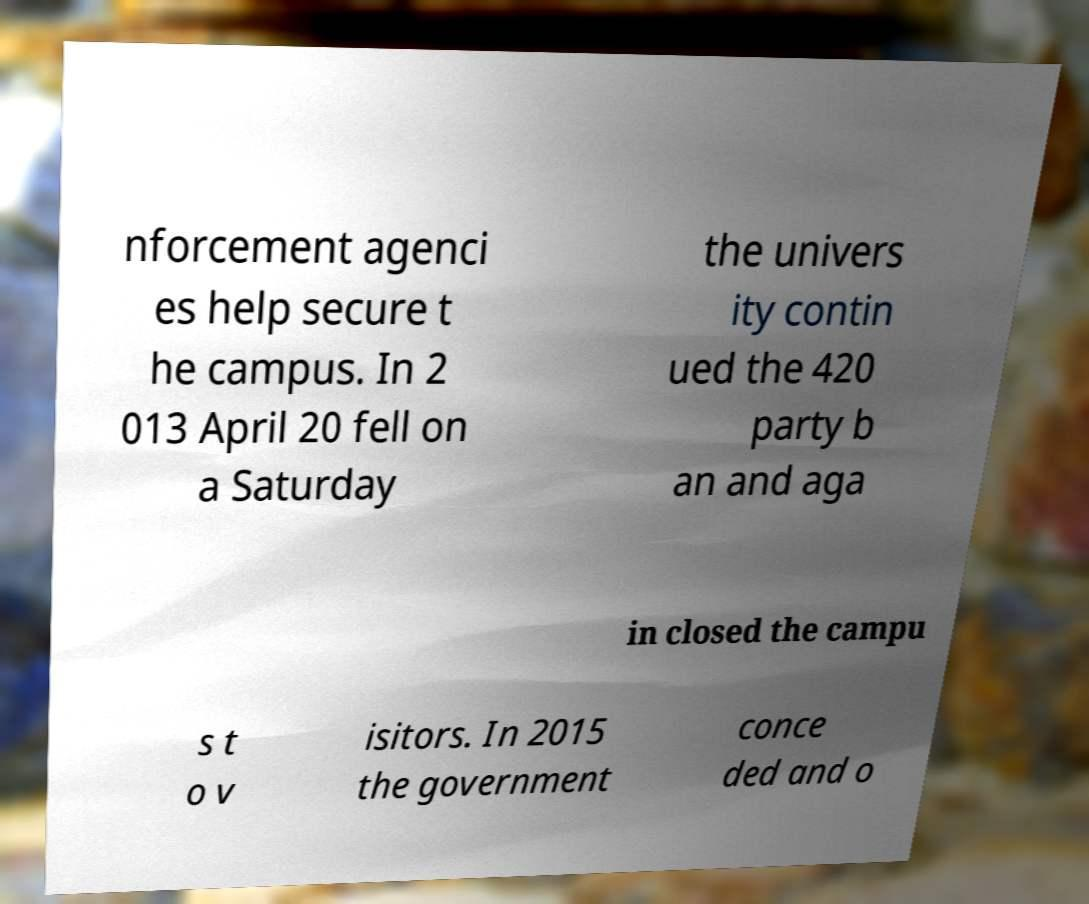Can you read and provide the text displayed in the image?This photo seems to have some interesting text. Can you extract and type it out for me? nforcement agenci es help secure t he campus. In 2 013 April 20 fell on a Saturday the univers ity contin ued the 420 party b an and aga in closed the campu s t o v isitors. In 2015 the government conce ded and o 